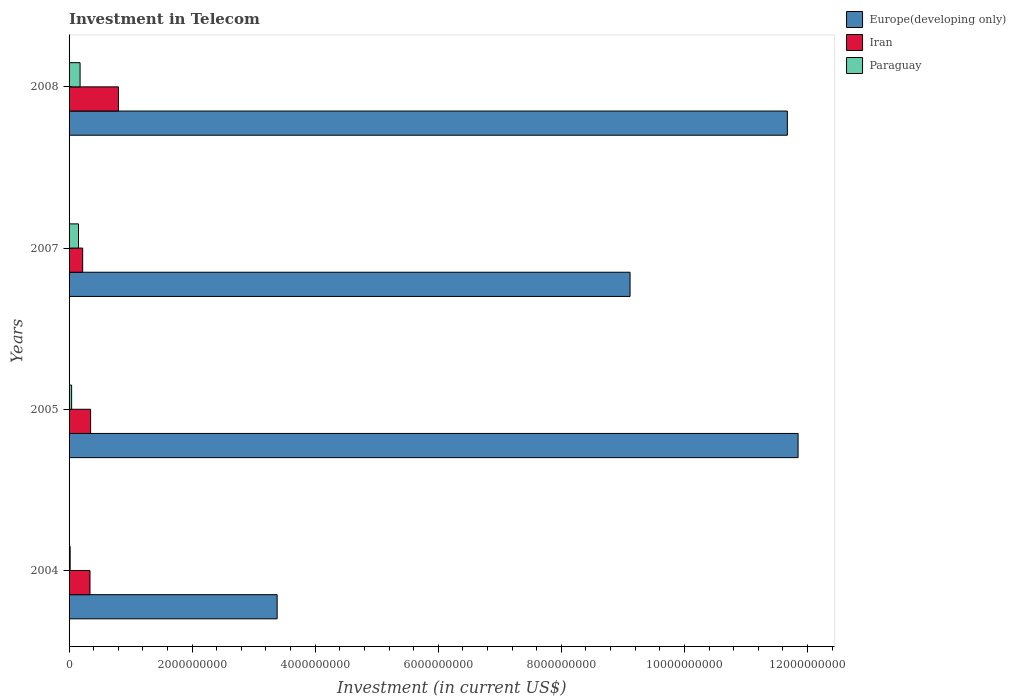Are the number of bars on each tick of the Y-axis equal?
Give a very brief answer. Yes. What is the label of the 2nd group of bars from the top?
Make the answer very short. 2007. In how many cases, is the number of bars for a given year not equal to the number of legend labels?
Give a very brief answer. 0. What is the amount invested in telecom in Paraguay in 2005?
Give a very brief answer. 4.14e+07. Across all years, what is the maximum amount invested in telecom in Paraguay?
Provide a short and direct response. 1.79e+08. Across all years, what is the minimum amount invested in telecom in Iran?
Give a very brief answer. 2.21e+08. In which year was the amount invested in telecom in Paraguay maximum?
Your response must be concise. 2008. In which year was the amount invested in telecom in Iran minimum?
Give a very brief answer. 2007. What is the total amount invested in telecom in Europe(developing only) in the graph?
Provide a succinct answer. 3.60e+1. What is the difference between the amount invested in telecom in Iran in 2004 and that in 2005?
Your answer should be compact. -1.00e+07. What is the difference between the amount invested in telecom in Europe(developing only) in 2004 and the amount invested in telecom in Paraguay in 2005?
Offer a very short reply. 3.34e+09. What is the average amount invested in telecom in Iran per year?
Provide a succinct answer. 4.28e+08. In the year 2008, what is the difference between the amount invested in telecom in Europe(developing only) and amount invested in telecom in Paraguay?
Offer a very short reply. 1.15e+1. What is the ratio of the amount invested in telecom in Iran in 2007 to that in 2008?
Provide a short and direct response. 0.28. Is the amount invested in telecom in Paraguay in 2007 less than that in 2008?
Offer a terse response. Yes. What is the difference between the highest and the second highest amount invested in telecom in Paraguay?
Ensure brevity in your answer.  2.56e+07. What is the difference between the highest and the lowest amount invested in telecom in Paraguay?
Ensure brevity in your answer.  1.61e+08. In how many years, is the amount invested in telecom in Iran greater than the average amount invested in telecom in Iran taken over all years?
Offer a very short reply. 1. What does the 1st bar from the top in 2005 represents?
Your response must be concise. Paraguay. What does the 2nd bar from the bottom in 2005 represents?
Offer a terse response. Iran. Is it the case that in every year, the sum of the amount invested in telecom in Europe(developing only) and amount invested in telecom in Paraguay is greater than the amount invested in telecom in Iran?
Your response must be concise. Yes. How many bars are there?
Make the answer very short. 12. How many years are there in the graph?
Your answer should be compact. 4. How many legend labels are there?
Your answer should be compact. 3. What is the title of the graph?
Keep it short and to the point. Investment in Telecom. What is the label or title of the X-axis?
Offer a very short reply. Investment (in current US$). What is the Investment (in current US$) of Europe(developing only) in 2004?
Your answer should be very brief. 3.38e+09. What is the Investment (in current US$) of Iran in 2004?
Give a very brief answer. 3.40e+08. What is the Investment (in current US$) of Paraguay in 2004?
Provide a short and direct response. 1.76e+07. What is the Investment (in current US$) in Europe(developing only) in 2005?
Ensure brevity in your answer.  1.18e+1. What is the Investment (in current US$) in Iran in 2005?
Offer a terse response. 3.50e+08. What is the Investment (in current US$) in Paraguay in 2005?
Offer a terse response. 4.14e+07. What is the Investment (in current US$) in Europe(developing only) in 2007?
Your answer should be very brief. 9.12e+09. What is the Investment (in current US$) in Iran in 2007?
Provide a short and direct response. 2.21e+08. What is the Investment (in current US$) in Paraguay in 2007?
Offer a terse response. 1.53e+08. What is the Investment (in current US$) of Europe(developing only) in 2008?
Ensure brevity in your answer.  1.17e+1. What is the Investment (in current US$) of Iran in 2008?
Your answer should be very brief. 8.02e+08. What is the Investment (in current US$) in Paraguay in 2008?
Your response must be concise. 1.79e+08. Across all years, what is the maximum Investment (in current US$) of Europe(developing only)?
Provide a short and direct response. 1.18e+1. Across all years, what is the maximum Investment (in current US$) in Iran?
Offer a very short reply. 8.02e+08. Across all years, what is the maximum Investment (in current US$) of Paraguay?
Offer a very short reply. 1.79e+08. Across all years, what is the minimum Investment (in current US$) of Europe(developing only)?
Offer a very short reply. 3.38e+09. Across all years, what is the minimum Investment (in current US$) in Iran?
Your response must be concise. 2.21e+08. Across all years, what is the minimum Investment (in current US$) of Paraguay?
Make the answer very short. 1.76e+07. What is the total Investment (in current US$) of Europe(developing only) in the graph?
Your answer should be very brief. 3.60e+1. What is the total Investment (in current US$) in Iran in the graph?
Your response must be concise. 1.71e+09. What is the total Investment (in current US$) in Paraguay in the graph?
Offer a very short reply. 3.91e+08. What is the difference between the Investment (in current US$) of Europe(developing only) in 2004 and that in 2005?
Offer a terse response. -8.47e+09. What is the difference between the Investment (in current US$) of Iran in 2004 and that in 2005?
Your answer should be compact. -1.00e+07. What is the difference between the Investment (in current US$) in Paraguay in 2004 and that in 2005?
Your answer should be compact. -2.38e+07. What is the difference between the Investment (in current US$) in Europe(developing only) in 2004 and that in 2007?
Offer a very short reply. -5.74e+09. What is the difference between the Investment (in current US$) in Iran in 2004 and that in 2007?
Give a very brief answer. 1.19e+08. What is the difference between the Investment (in current US$) in Paraguay in 2004 and that in 2007?
Your response must be concise. -1.36e+08. What is the difference between the Investment (in current US$) of Europe(developing only) in 2004 and that in 2008?
Your response must be concise. -8.29e+09. What is the difference between the Investment (in current US$) in Iran in 2004 and that in 2008?
Ensure brevity in your answer.  -4.62e+08. What is the difference between the Investment (in current US$) in Paraguay in 2004 and that in 2008?
Provide a short and direct response. -1.61e+08. What is the difference between the Investment (in current US$) of Europe(developing only) in 2005 and that in 2007?
Offer a terse response. 2.73e+09. What is the difference between the Investment (in current US$) in Iran in 2005 and that in 2007?
Keep it short and to the point. 1.29e+08. What is the difference between the Investment (in current US$) in Paraguay in 2005 and that in 2007?
Give a very brief answer. -1.12e+08. What is the difference between the Investment (in current US$) in Europe(developing only) in 2005 and that in 2008?
Your response must be concise. 1.75e+08. What is the difference between the Investment (in current US$) in Iran in 2005 and that in 2008?
Offer a terse response. -4.52e+08. What is the difference between the Investment (in current US$) of Paraguay in 2005 and that in 2008?
Make the answer very short. -1.37e+08. What is the difference between the Investment (in current US$) of Europe(developing only) in 2007 and that in 2008?
Make the answer very short. -2.56e+09. What is the difference between the Investment (in current US$) of Iran in 2007 and that in 2008?
Ensure brevity in your answer.  -5.81e+08. What is the difference between the Investment (in current US$) in Paraguay in 2007 and that in 2008?
Give a very brief answer. -2.56e+07. What is the difference between the Investment (in current US$) in Europe(developing only) in 2004 and the Investment (in current US$) in Iran in 2005?
Provide a succinct answer. 3.03e+09. What is the difference between the Investment (in current US$) in Europe(developing only) in 2004 and the Investment (in current US$) in Paraguay in 2005?
Your response must be concise. 3.34e+09. What is the difference between the Investment (in current US$) of Iran in 2004 and the Investment (in current US$) of Paraguay in 2005?
Offer a very short reply. 2.99e+08. What is the difference between the Investment (in current US$) of Europe(developing only) in 2004 and the Investment (in current US$) of Iran in 2007?
Your response must be concise. 3.16e+09. What is the difference between the Investment (in current US$) of Europe(developing only) in 2004 and the Investment (in current US$) of Paraguay in 2007?
Ensure brevity in your answer.  3.23e+09. What is the difference between the Investment (in current US$) of Iran in 2004 and the Investment (in current US$) of Paraguay in 2007?
Your answer should be compact. 1.87e+08. What is the difference between the Investment (in current US$) in Europe(developing only) in 2004 and the Investment (in current US$) in Iran in 2008?
Offer a terse response. 2.58e+09. What is the difference between the Investment (in current US$) in Europe(developing only) in 2004 and the Investment (in current US$) in Paraguay in 2008?
Provide a short and direct response. 3.20e+09. What is the difference between the Investment (in current US$) in Iran in 2004 and the Investment (in current US$) in Paraguay in 2008?
Offer a terse response. 1.61e+08. What is the difference between the Investment (in current US$) in Europe(developing only) in 2005 and the Investment (in current US$) in Iran in 2007?
Make the answer very short. 1.16e+1. What is the difference between the Investment (in current US$) in Europe(developing only) in 2005 and the Investment (in current US$) in Paraguay in 2007?
Offer a very short reply. 1.17e+1. What is the difference between the Investment (in current US$) in Iran in 2005 and the Investment (in current US$) in Paraguay in 2007?
Your answer should be compact. 1.97e+08. What is the difference between the Investment (in current US$) in Europe(developing only) in 2005 and the Investment (in current US$) in Iran in 2008?
Keep it short and to the point. 1.10e+1. What is the difference between the Investment (in current US$) of Europe(developing only) in 2005 and the Investment (in current US$) of Paraguay in 2008?
Ensure brevity in your answer.  1.17e+1. What is the difference between the Investment (in current US$) of Iran in 2005 and the Investment (in current US$) of Paraguay in 2008?
Your response must be concise. 1.71e+08. What is the difference between the Investment (in current US$) in Europe(developing only) in 2007 and the Investment (in current US$) in Iran in 2008?
Your answer should be very brief. 8.32e+09. What is the difference between the Investment (in current US$) of Europe(developing only) in 2007 and the Investment (in current US$) of Paraguay in 2008?
Make the answer very short. 8.94e+09. What is the difference between the Investment (in current US$) of Iran in 2007 and the Investment (in current US$) of Paraguay in 2008?
Your response must be concise. 4.22e+07. What is the average Investment (in current US$) of Europe(developing only) per year?
Give a very brief answer. 9.00e+09. What is the average Investment (in current US$) of Iran per year?
Keep it short and to the point. 4.28e+08. What is the average Investment (in current US$) in Paraguay per year?
Provide a short and direct response. 9.78e+07. In the year 2004, what is the difference between the Investment (in current US$) of Europe(developing only) and Investment (in current US$) of Iran?
Offer a terse response. 3.04e+09. In the year 2004, what is the difference between the Investment (in current US$) in Europe(developing only) and Investment (in current US$) in Paraguay?
Provide a short and direct response. 3.36e+09. In the year 2004, what is the difference between the Investment (in current US$) of Iran and Investment (in current US$) of Paraguay?
Your answer should be very brief. 3.22e+08. In the year 2005, what is the difference between the Investment (in current US$) of Europe(developing only) and Investment (in current US$) of Iran?
Your answer should be very brief. 1.15e+1. In the year 2005, what is the difference between the Investment (in current US$) in Europe(developing only) and Investment (in current US$) in Paraguay?
Provide a short and direct response. 1.18e+1. In the year 2005, what is the difference between the Investment (in current US$) of Iran and Investment (in current US$) of Paraguay?
Your answer should be very brief. 3.09e+08. In the year 2007, what is the difference between the Investment (in current US$) in Europe(developing only) and Investment (in current US$) in Iran?
Offer a very short reply. 8.90e+09. In the year 2007, what is the difference between the Investment (in current US$) in Europe(developing only) and Investment (in current US$) in Paraguay?
Provide a succinct answer. 8.96e+09. In the year 2007, what is the difference between the Investment (in current US$) of Iran and Investment (in current US$) of Paraguay?
Your answer should be very brief. 6.78e+07. In the year 2008, what is the difference between the Investment (in current US$) of Europe(developing only) and Investment (in current US$) of Iran?
Provide a short and direct response. 1.09e+1. In the year 2008, what is the difference between the Investment (in current US$) of Europe(developing only) and Investment (in current US$) of Paraguay?
Provide a short and direct response. 1.15e+1. In the year 2008, what is the difference between the Investment (in current US$) in Iran and Investment (in current US$) in Paraguay?
Offer a very short reply. 6.23e+08. What is the ratio of the Investment (in current US$) of Europe(developing only) in 2004 to that in 2005?
Provide a short and direct response. 0.29. What is the ratio of the Investment (in current US$) of Iran in 2004 to that in 2005?
Your answer should be very brief. 0.97. What is the ratio of the Investment (in current US$) of Paraguay in 2004 to that in 2005?
Offer a terse response. 0.43. What is the ratio of the Investment (in current US$) of Europe(developing only) in 2004 to that in 2007?
Make the answer very short. 0.37. What is the ratio of the Investment (in current US$) of Iran in 2004 to that in 2007?
Your answer should be compact. 1.54. What is the ratio of the Investment (in current US$) of Paraguay in 2004 to that in 2007?
Your response must be concise. 0.11. What is the ratio of the Investment (in current US$) of Europe(developing only) in 2004 to that in 2008?
Your response must be concise. 0.29. What is the ratio of the Investment (in current US$) of Iran in 2004 to that in 2008?
Your answer should be very brief. 0.42. What is the ratio of the Investment (in current US$) of Paraguay in 2004 to that in 2008?
Offer a terse response. 0.1. What is the ratio of the Investment (in current US$) in Europe(developing only) in 2005 to that in 2007?
Your answer should be very brief. 1.3. What is the ratio of the Investment (in current US$) in Iran in 2005 to that in 2007?
Your answer should be compact. 1.58. What is the ratio of the Investment (in current US$) in Paraguay in 2005 to that in 2007?
Your answer should be very brief. 0.27. What is the ratio of the Investment (in current US$) of Europe(developing only) in 2005 to that in 2008?
Your response must be concise. 1.01. What is the ratio of the Investment (in current US$) of Iran in 2005 to that in 2008?
Ensure brevity in your answer.  0.44. What is the ratio of the Investment (in current US$) in Paraguay in 2005 to that in 2008?
Your answer should be compact. 0.23. What is the ratio of the Investment (in current US$) of Europe(developing only) in 2007 to that in 2008?
Keep it short and to the point. 0.78. What is the ratio of the Investment (in current US$) in Iran in 2007 to that in 2008?
Your response must be concise. 0.28. What is the ratio of the Investment (in current US$) in Paraguay in 2007 to that in 2008?
Your answer should be compact. 0.86. What is the difference between the highest and the second highest Investment (in current US$) of Europe(developing only)?
Provide a short and direct response. 1.75e+08. What is the difference between the highest and the second highest Investment (in current US$) in Iran?
Give a very brief answer. 4.52e+08. What is the difference between the highest and the second highest Investment (in current US$) in Paraguay?
Your answer should be compact. 2.56e+07. What is the difference between the highest and the lowest Investment (in current US$) of Europe(developing only)?
Give a very brief answer. 8.47e+09. What is the difference between the highest and the lowest Investment (in current US$) in Iran?
Give a very brief answer. 5.81e+08. What is the difference between the highest and the lowest Investment (in current US$) of Paraguay?
Your answer should be compact. 1.61e+08. 